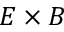<formula> <loc_0><loc_0><loc_500><loc_500>E \times B</formula> 